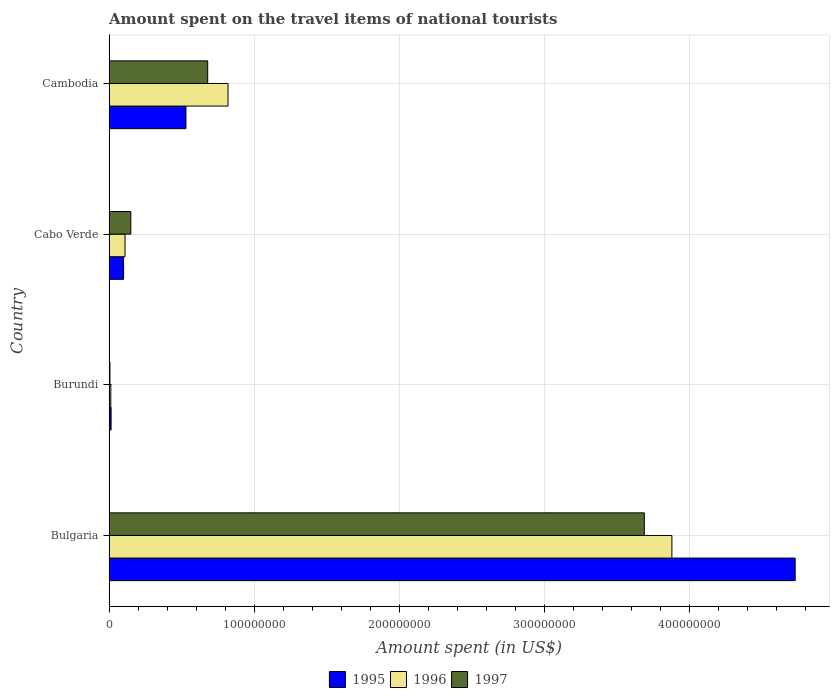How many different coloured bars are there?
Give a very brief answer. 3. How many groups of bars are there?
Your answer should be compact. 4. Are the number of bars on each tick of the Y-axis equal?
Offer a very short reply. Yes. What is the label of the 3rd group of bars from the top?
Your answer should be very brief. Burundi. What is the amount spent on the travel items of national tourists in 1996 in Bulgaria?
Provide a succinct answer. 3.88e+08. Across all countries, what is the maximum amount spent on the travel items of national tourists in 1996?
Ensure brevity in your answer.  3.88e+08. In which country was the amount spent on the travel items of national tourists in 1996 minimum?
Provide a short and direct response. Burundi. What is the total amount spent on the travel items of national tourists in 1997 in the graph?
Provide a succinct answer. 4.53e+08. What is the difference between the amount spent on the travel items of national tourists in 1995 in Burundi and that in Cabo Verde?
Your response must be concise. -8.60e+06. What is the difference between the amount spent on the travel items of national tourists in 1995 in Burundi and the amount spent on the travel items of national tourists in 1997 in Cabo Verde?
Your response must be concise. -1.36e+07. What is the average amount spent on the travel items of national tourists in 1995 per country?
Keep it short and to the point. 1.34e+08. What is the difference between the amount spent on the travel items of national tourists in 1995 and amount spent on the travel items of national tourists in 1997 in Burundi?
Provide a succinct answer. 8.00e+05. In how many countries, is the amount spent on the travel items of national tourists in 1995 greater than 440000000 US$?
Offer a very short reply. 1. What is the ratio of the amount spent on the travel items of national tourists in 1995 in Bulgaria to that in Burundi?
Your answer should be compact. 337.86. Is the amount spent on the travel items of national tourists in 1995 in Burundi less than that in Cambodia?
Offer a very short reply. Yes. Is the difference between the amount spent on the travel items of national tourists in 1995 in Cabo Verde and Cambodia greater than the difference between the amount spent on the travel items of national tourists in 1997 in Cabo Verde and Cambodia?
Your answer should be compact. Yes. What is the difference between the highest and the second highest amount spent on the travel items of national tourists in 1997?
Offer a very short reply. 3.01e+08. What is the difference between the highest and the lowest amount spent on the travel items of national tourists in 1997?
Give a very brief answer. 3.68e+08. What does the 3rd bar from the top in Cambodia represents?
Your answer should be compact. 1995. Are all the bars in the graph horizontal?
Provide a short and direct response. Yes. How many countries are there in the graph?
Your answer should be compact. 4. Are the values on the major ticks of X-axis written in scientific E-notation?
Give a very brief answer. No. Does the graph contain grids?
Your answer should be very brief. Yes. How many legend labels are there?
Your response must be concise. 3. How are the legend labels stacked?
Provide a succinct answer. Horizontal. What is the title of the graph?
Make the answer very short. Amount spent on the travel items of national tourists. Does "2010" appear as one of the legend labels in the graph?
Offer a terse response. No. What is the label or title of the X-axis?
Give a very brief answer. Amount spent (in US$). What is the label or title of the Y-axis?
Give a very brief answer. Country. What is the Amount spent (in US$) of 1995 in Bulgaria?
Your response must be concise. 4.73e+08. What is the Amount spent (in US$) of 1996 in Bulgaria?
Make the answer very short. 3.88e+08. What is the Amount spent (in US$) in 1997 in Bulgaria?
Provide a succinct answer. 3.69e+08. What is the Amount spent (in US$) in 1995 in Burundi?
Your answer should be very brief. 1.40e+06. What is the Amount spent (in US$) of 1996 in Burundi?
Give a very brief answer. 1.20e+06. What is the Amount spent (in US$) of 1997 in Burundi?
Your response must be concise. 6.00e+05. What is the Amount spent (in US$) in 1995 in Cabo Verde?
Provide a short and direct response. 1.00e+07. What is the Amount spent (in US$) in 1996 in Cabo Verde?
Ensure brevity in your answer.  1.10e+07. What is the Amount spent (in US$) in 1997 in Cabo Verde?
Keep it short and to the point. 1.50e+07. What is the Amount spent (in US$) of 1995 in Cambodia?
Provide a succinct answer. 5.30e+07. What is the Amount spent (in US$) in 1996 in Cambodia?
Your answer should be very brief. 8.20e+07. What is the Amount spent (in US$) of 1997 in Cambodia?
Offer a very short reply. 6.80e+07. Across all countries, what is the maximum Amount spent (in US$) in 1995?
Your answer should be very brief. 4.73e+08. Across all countries, what is the maximum Amount spent (in US$) of 1996?
Ensure brevity in your answer.  3.88e+08. Across all countries, what is the maximum Amount spent (in US$) of 1997?
Keep it short and to the point. 3.69e+08. Across all countries, what is the minimum Amount spent (in US$) of 1995?
Make the answer very short. 1.40e+06. Across all countries, what is the minimum Amount spent (in US$) of 1996?
Your answer should be compact. 1.20e+06. What is the total Amount spent (in US$) of 1995 in the graph?
Keep it short and to the point. 5.37e+08. What is the total Amount spent (in US$) of 1996 in the graph?
Offer a terse response. 4.82e+08. What is the total Amount spent (in US$) in 1997 in the graph?
Your answer should be compact. 4.53e+08. What is the difference between the Amount spent (in US$) of 1995 in Bulgaria and that in Burundi?
Give a very brief answer. 4.72e+08. What is the difference between the Amount spent (in US$) of 1996 in Bulgaria and that in Burundi?
Ensure brevity in your answer.  3.87e+08. What is the difference between the Amount spent (in US$) in 1997 in Bulgaria and that in Burundi?
Your answer should be very brief. 3.68e+08. What is the difference between the Amount spent (in US$) of 1995 in Bulgaria and that in Cabo Verde?
Keep it short and to the point. 4.63e+08. What is the difference between the Amount spent (in US$) of 1996 in Bulgaria and that in Cabo Verde?
Offer a very short reply. 3.77e+08. What is the difference between the Amount spent (in US$) of 1997 in Bulgaria and that in Cabo Verde?
Make the answer very short. 3.54e+08. What is the difference between the Amount spent (in US$) of 1995 in Bulgaria and that in Cambodia?
Give a very brief answer. 4.20e+08. What is the difference between the Amount spent (in US$) of 1996 in Bulgaria and that in Cambodia?
Your answer should be very brief. 3.06e+08. What is the difference between the Amount spent (in US$) of 1997 in Bulgaria and that in Cambodia?
Your answer should be compact. 3.01e+08. What is the difference between the Amount spent (in US$) of 1995 in Burundi and that in Cabo Verde?
Give a very brief answer. -8.60e+06. What is the difference between the Amount spent (in US$) in 1996 in Burundi and that in Cabo Verde?
Offer a very short reply. -9.80e+06. What is the difference between the Amount spent (in US$) of 1997 in Burundi and that in Cabo Verde?
Offer a terse response. -1.44e+07. What is the difference between the Amount spent (in US$) of 1995 in Burundi and that in Cambodia?
Your answer should be compact. -5.16e+07. What is the difference between the Amount spent (in US$) of 1996 in Burundi and that in Cambodia?
Make the answer very short. -8.08e+07. What is the difference between the Amount spent (in US$) in 1997 in Burundi and that in Cambodia?
Your answer should be compact. -6.74e+07. What is the difference between the Amount spent (in US$) of 1995 in Cabo Verde and that in Cambodia?
Provide a short and direct response. -4.30e+07. What is the difference between the Amount spent (in US$) of 1996 in Cabo Verde and that in Cambodia?
Your answer should be compact. -7.10e+07. What is the difference between the Amount spent (in US$) of 1997 in Cabo Verde and that in Cambodia?
Give a very brief answer. -5.30e+07. What is the difference between the Amount spent (in US$) in 1995 in Bulgaria and the Amount spent (in US$) in 1996 in Burundi?
Provide a succinct answer. 4.72e+08. What is the difference between the Amount spent (in US$) in 1995 in Bulgaria and the Amount spent (in US$) in 1997 in Burundi?
Provide a succinct answer. 4.72e+08. What is the difference between the Amount spent (in US$) in 1996 in Bulgaria and the Amount spent (in US$) in 1997 in Burundi?
Offer a very short reply. 3.87e+08. What is the difference between the Amount spent (in US$) in 1995 in Bulgaria and the Amount spent (in US$) in 1996 in Cabo Verde?
Provide a succinct answer. 4.62e+08. What is the difference between the Amount spent (in US$) in 1995 in Bulgaria and the Amount spent (in US$) in 1997 in Cabo Verde?
Your answer should be compact. 4.58e+08. What is the difference between the Amount spent (in US$) in 1996 in Bulgaria and the Amount spent (in US$) in 1997 in Cabo Verde?
Ensure brevity in your answer.  3.73e+08. What is the difference between the Amount spent (in US$) in 1995 in Bulgaria and the Amount spent (in US$) in 1996 in Cambodia?
Give a very brief answer. 3.91e+08. What is the difference between the Amount spent (in US$) of 1995 in Bulgaria and the Amount spent (in US$) of 1997 in Cambodia?
Give a very brief answer. 4.05e+08. What is the difference between the Amount spent (in US$) in 1996 in Bulgaria and the Amount spent (in US$) in 1997 in Cambodia?
Offer a terse response. 3.20e+08. What is the difference between the Amount spent (in US$) in 1995 in Burundi and the Amount spent (in US$) in 1996 in Cabo Verde?
Offer a terse response. -9.60e+06. What is the difference between the Amount spent (in US$) of 1995 in Burundi and the Amount spent (in US$) of 1997 in Cabo Verde?
Make the answer very short. -1.36e+07. What is the difference between the Amount spent (in US$) in 1996 in Burundi and the Amount spent (in US$) in 1997 in Cabo Verde?
Make the answer very short. -1.38e+07. What is the difference between the Amount spent (in US$) of 1995 in Burundi and the Amount spent (in US$) of 1996 in Cambodia?
Your answer should be compact. -8.06e+07. What is the difference between the Amount spent (in US$) in 1995 in Burundi and the Amount spent (in US$) in 1997 in Cambodia?
Your answer should be very brief. -6.66e+07. What is the difference between the Amount spent (in US$) of 1996 in Burundi and the Amount spent (in US$) of 1997 in Cambodia?
Offer a terse response. -6.68e+07. What is the difference between the Amount spent (in US$) of 1995 in Cabo Verde and the Amount spent (in US$) of 1996 in Cambodia?
Make the answer very short. -7.20e+07. What is the difference between the Amount spent (in US$) of 1995 in Cabo Verde and the Amount spent (in US$) of 1997 in Cambodia?
Make the answer very short. -5.80e+07. What is the difference between the Amount spent (in US$) of 1996 in Cabo Verde and the Amount spent (in US$) of 1997 in Cambodia?
Offer a very short reply. -5.70e+07. What is the average Amount spent (in US$) in 1995 per country?
Keep it short and to the point. 1.34e+08. What is the average Amount spent (in US$) of 1996 per country?
Offer a terse response. 1.21e+08. What is the average Amount spent (in US$) of 1997 per country?
Offer a terse response. 1.13e+08. What is the difference between the Amount spent (in US$) of 1995 and Amount spent (in US$) of 1996 in Bulgaria?
Your answer should be very brief. 8.50e+07. What is the difference between the Amount spent (in US$) in 1995 and Amount spent (in US$) in 1997 in Bulgaria?
Provide a short and direct response. 1.04e+08. What is the difference between the Amount spent (in US$) in 1996 and Amount spent (in US$) in 1997 in Bulgaria?
Ensure brevity in your answer.  1.90e+07. What is the difference between the Amount spent (in US$) of 1995 and Amount spent (in US$) of 1996 in Burundi?
Provide a short and direct response. 2.00e+05. What is the difference between the Amount spent (in US$) of 1995 and Amount spent (in US$) of 1996 in Cabo Verde?
Make the answer very short. -1.00e+06. What is the difference between the Amount spent (in US$) in 1995 and Amount spent (in US$) in 1997 in Cabo Verde?
Provide a succinct answer. -5.00e+06. What is the difference between the Amount spent (in US$) in 1995 and Amount spent (in US$) in 1996 in Cambodia?
Keep it short and to the point. -2.90e+07. What is the difference between the Amount spent (in US$) of 1995 and Amount spent (in US$) of 1997 in Cambodia?
Ensure brevity in your answer.  -1.50e+07. What is the difference between the Amount spent (in US$) of 1996 and Amount spent (in US$) of 1997 in Cambodia?
Make the answer very short. 1.40e+07. What is the ratio of the Amount spent (in US$) in 1995 in Bulgaria to that in Burundi?
Offer a terse response. 337.86. What is the ratio of the Amount spent (in US$) of 1996 in Bulgaria to that in Burundi?
Offer a terse response. 323.33. What is the ratio of the Amount spent (in US$) in 1997 in Bulgaria to that in Burundi?
Your answer should be very brief. 615. What is the ratio of the Amount spent (in US$) in 1995 in Bulgaria to that in Cabo Verde?
Give a very brief answer. 47.3. What is the ratio of the Amount spent (in US$) in 1996 in Bulgaria to that in Cabo Verde?
Your answer should be compact. 35.27. What is the ratio of the Amount spent (in US$) in 1997 in Bulgaria to that in Cabo Verde?
Your answer should be compact. 24.6. What is the ratio of the Amount spent (in US$) in 1995 in Bulgaria to that in Cambodia?
Provide a short and direct response. 8.92. What is the ratio of the Amount spent (in US$) of 1996 in Bulgaria to that in Cambodia?
Your answer should be compact. 4.73. What is the ratio of the Amount spent (in US$) in 1997 in Bulgaria to that in Cambodia?
Ensure brevity in your answer.  5.43. What is the ratio of the Amount spent (in US$) in 1995 in Burundi to that in Cabo Verde?
Keep it short and to the point. 0.14. What is the ratio of the Amount spent (in US$) in 1996 in Burundi to that in Cabo Verde?
Ensure brevity in your answer.  0.11. What is the ratio of the Amount spent (in US$) of 1997 in Burundi to that in Cabo Verde?
Provide a succinct answer. 0.04. What is the ratio of the Amount spent (in US$) in 1995 in Burundi to that in Cambodia?
Your answer should be compact. 0.03. What is the ratio of the Amount spent (in US$) in 1996 in Burundi to that in Cambodia?
Provide a succinct answer. 0.01. What is the ratio of the Amount spent (in US$) in 1997 in Burundi to that in Cambodia?
Your answer should be compact. 0.01. What is the ratio of the Amount spent (in US$) in 1995 in Cabo Verde to that in Cambodia?
Provide a succinct answer. 0.19. What is the ratio of the Amount spent (in US$) in 1996 in Cabo Verde to that in Cambodia?
Your answer should be compact. 0.13. What is the ratio of the Amount spent (in US$) of 1997 in Cabo Verde to that in Cambodia?
Provide a short and direct response. 0.22. What is the difference between the highest and the second highest Amount spent (in US$) of 1995?
Your response must be concise. 4.20e+08. What is the difference between the highest and the second highest Amount spent (in US$) in 1996?
Your response must be concise. 3.06e+08. What is the difference between the highest and the second highest Amount spent (in US$) of 1997?
Your answer should be very brief. 3.01e+08. What is the difference between the highest and the lowest Amount spent (in US$) in 1995?
Provide a short and direct response. 4.72e+08. What is the difference between the highest and the lowest Amount spent (in US$) in 1996?
Offer a terse response. 3.87e+08. What is the difference between the highest and the lowest Amount spent (in US$) in 1997?
Offer a terse response. 3.68e+08. 